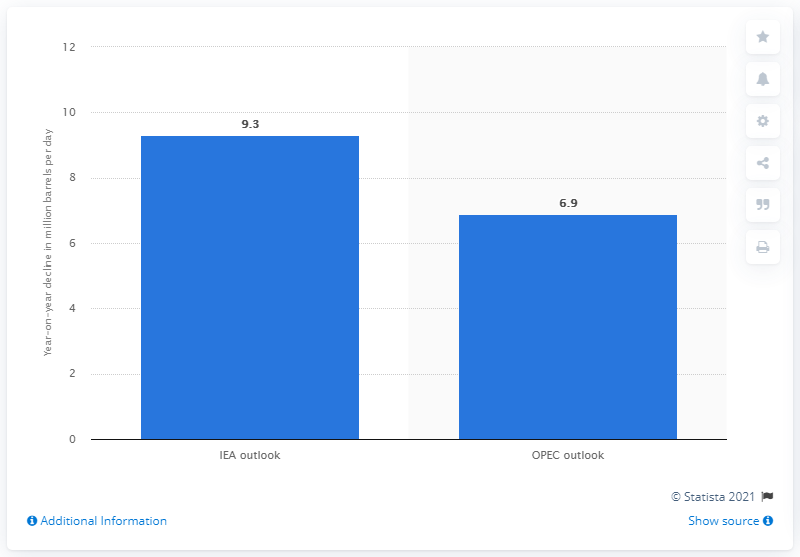Specify some key components in this picture. The International Energy Agency forecasts a decline of 9.3% in global oil demand in 2020. 